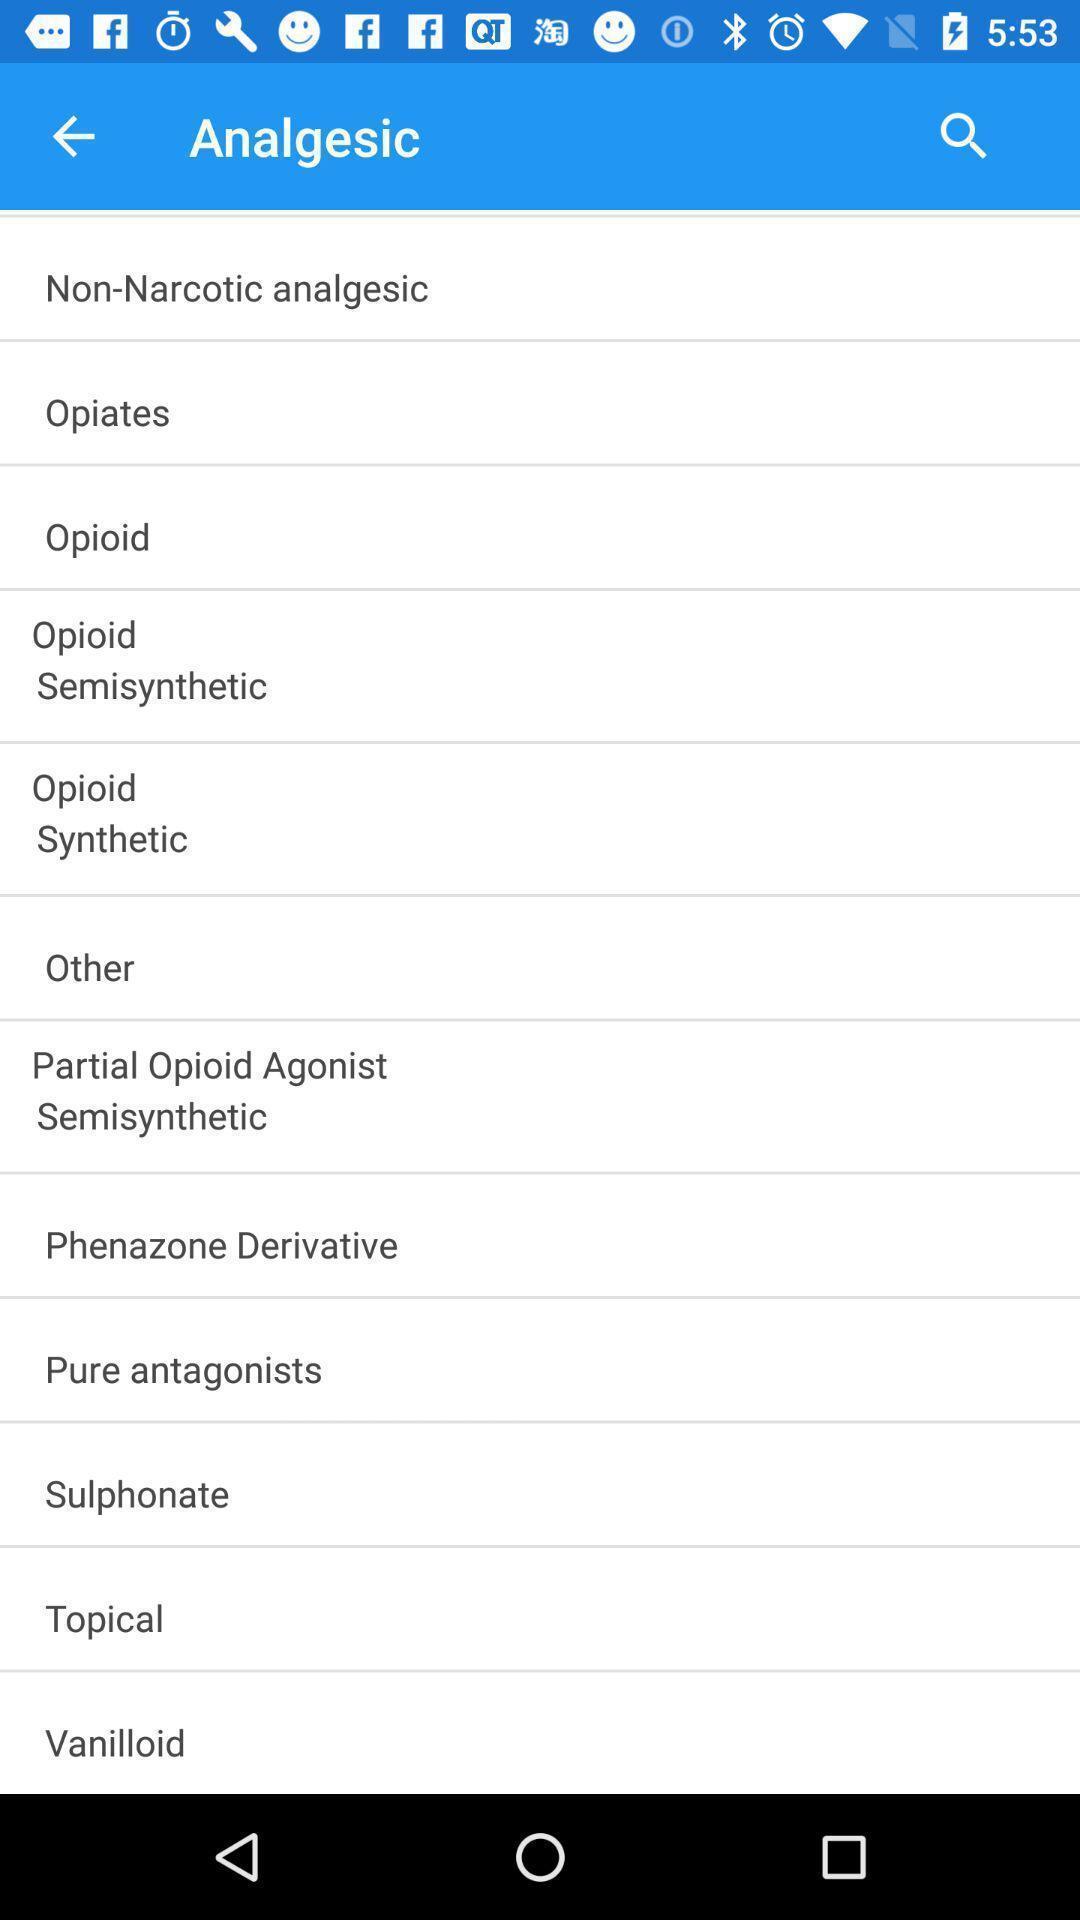Provide a detailed account of this screenshot. Screen showing analgesic. 